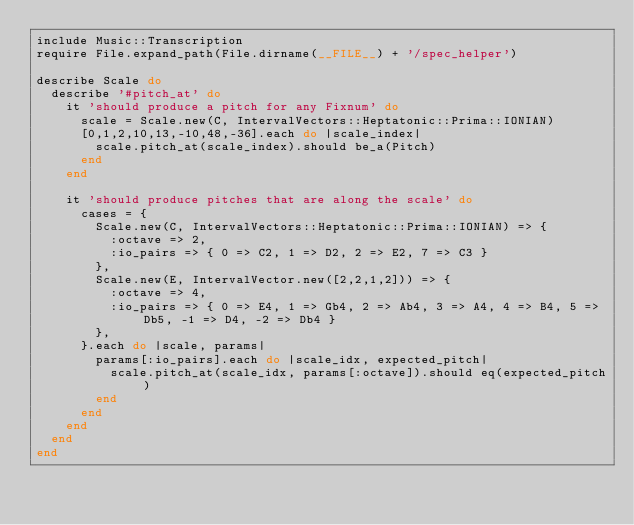<code> <loc_0><loc_0><loc_500><loc_500><_Ruby_>include Music::Transcription
require File.expand_path(File.dirname(__FILE__) + '/spec_helper')

describe Scale do
  describe '#pitch_at' do
    it 'should produce a pitch for any Fixnum' do
      scale = Scale.new(C, IntervalVectors::Heptatonic::Prima::IONIAN)
      [0,1,2,10,13,-10,48,-36].each do |scale_index|
        scale.pitch_at(scale_index).should be_a(Pitch)
      end
    end
    
    it 'should produce pitches that are along the scale' do
      cases = {
        Scale.new(C, IntervalVectors::Heptatonic::Prima::IONIAN) => {
          :octave => 2,
          :io_pairs => { 0 => C2, 1 => D2, 2 => E2, 7 => C3 }
        },
        Scale.new(E, IntervalVector.new([2,2,1,2])) => {
          :octave => 4,
          :io_pairs => { 0 => E4, 1 => Gb4, 2 => Ab4, 3 => A4, 4 => B4, 5 => Db5, -1 => D4, -2 => Db4 }
        },
      }.each do |scale, params|
        params[:io_pairs].each do |scale_idx, expected_pitch|
          scale.pitch_at(scale_idx, params[:octave]).should eq(expected_pitch)
        end
      end
    end
  end
end
</code> 